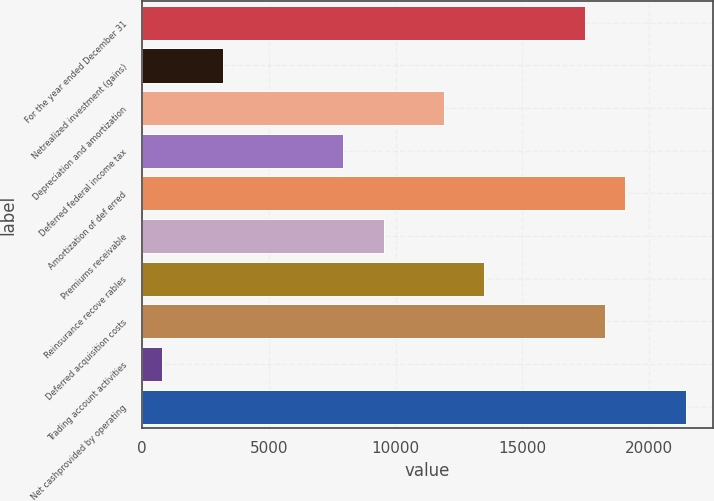Convert chart. <chart><loc_0><loc_0><loc_500><loc_500><bar_chart><fcel>For the year ended December 31<fcel>Netrealized investment (gains)<fcel>Depreciation and amortization<fcel>Deferred federal income tax<fcel>Amortization of def erred<fcel>Premiums receivable<fcel>Reinsurance recove rables<fcel>Deferred acquisition costs<fcel>Trading account activities<fcel>Net cashprovided by operating<nl><fcel>17470.6<fcel>3182.2<fcel>11914<fcel>7945<fcel>19058.2<fcel>9532.6<fcel>13501.6<fcel>18264.4<fcel>800.8<fcel>21439.6<nl></chart> 